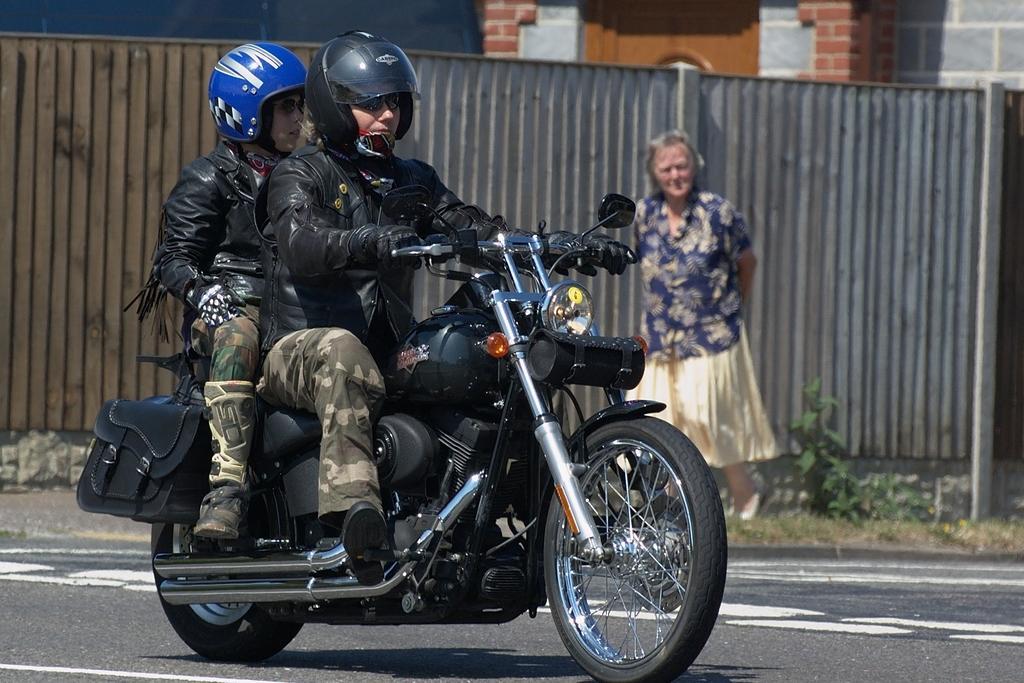Can you describe this image briefly? In this image , There is road ,In the middle there is a bike of black color on that bike there are two persons sitting in the background there is a wall and a woman standing. 